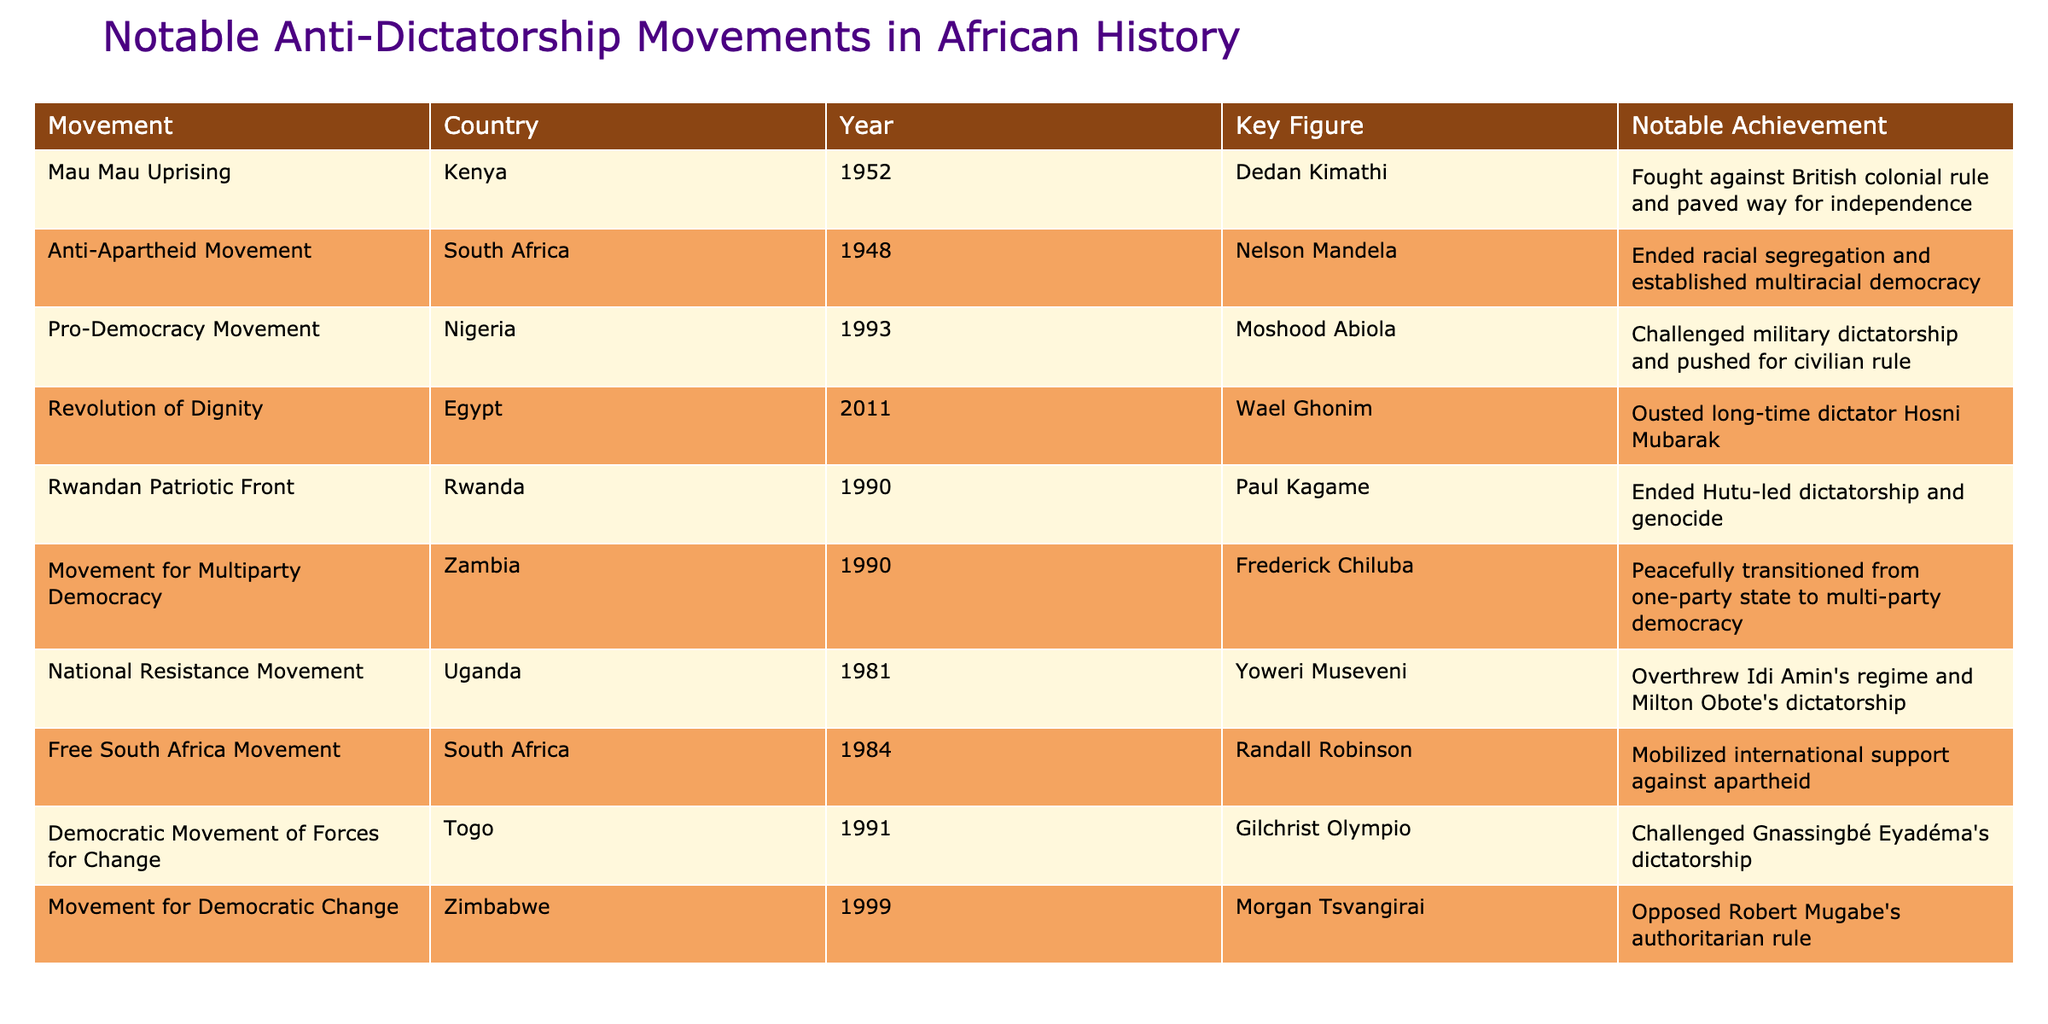What year did the Mau Mau Uprising occur? The table lists various movements along with their corresponding years. Looking at the "Mau Mau Uprising" row, we can find that it is associated with the year 1952.
Answer: 1952 Who was the key figure in the Anti-Apartheid Movement? The table provides a column for "Key Figure" associated with each movement. In the row for the "Anti-Apartheid Movement," the key figure is Nelson Mandela.
Answer: Nelson Mandela True or false: The Movement for Multiparty Democracy was initiated in South Africa. The location of the "Movement for Multiparty Democracy" can be found in the "Country" column of the table. It shows that this movement took place in Zambia, not South Africa.
Answer: False How many movements mentioned in the table occurred in the 1990s? To answer this, we must count the rows where the year is between 1990 and 1999. The following movements fall within this range: "Rwandan Patriotic Front" (1990), "Movement for Multiparty Democracy" (1990), "Democratic Movement of Forces for Change" (1991), and "Movement for Democratic Change" (1999). This totals to 4 movements.
Answer: 4 Which movement was associated with the most recent key figure listed? The final row of the table indicates the "Movement for Democratic Change," with Morgan Tsvangirai as its key figure from the year 1999. A quick look at the years confirms that this is the most recent movement listed in the table.
Answer: Morgan Tsvangirai 